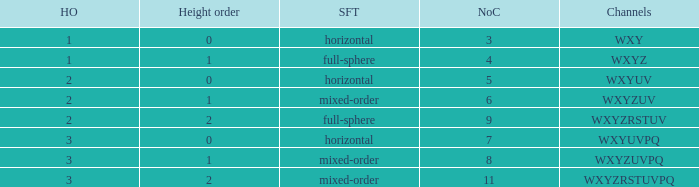If the channels is wxyzuv, what is the number of channels? 6.0. 